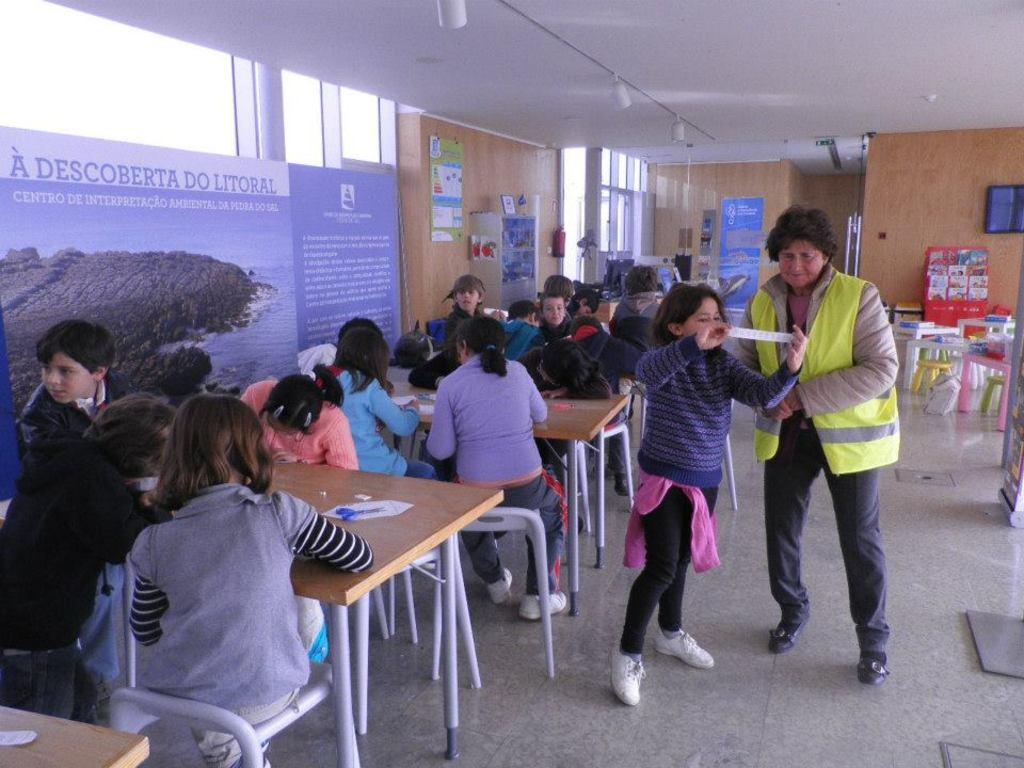Can you describe this image briefly? In this picture we can see a group of persons,some persons are sitting on chairs,some persons are standing,beside to these persons we can see some objects,board,wall,roof. 